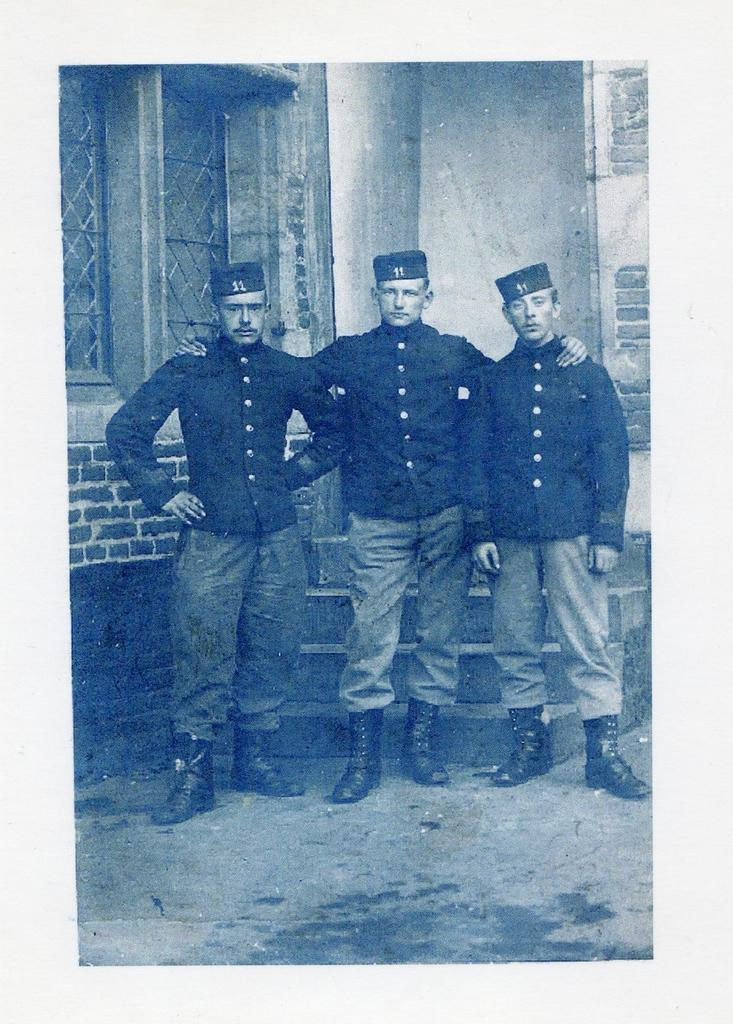How many men are in the image? There are three men in the image. What are the men doing in the image? The men are standing in the image. What are the men wearing on their heads? The men are wearing caps in the image. What type of clothing are the men wearing on their upper bodies? The men are wearing shirts in the image. What type of clothing are the men wearing on their lower bodies? The men are wearing trousers in the image. What type of shoes are the men wearing? The men are wearing black color shoes in the image. What can be seen in the background of the image? There is a brick wall in the background of the image. What type of disease is affecting the men in the image? There is no indication of any disease affecting the men in the image. How many steps can be seen in the image? There are no steps visible in the image; it only shows three men standing. 